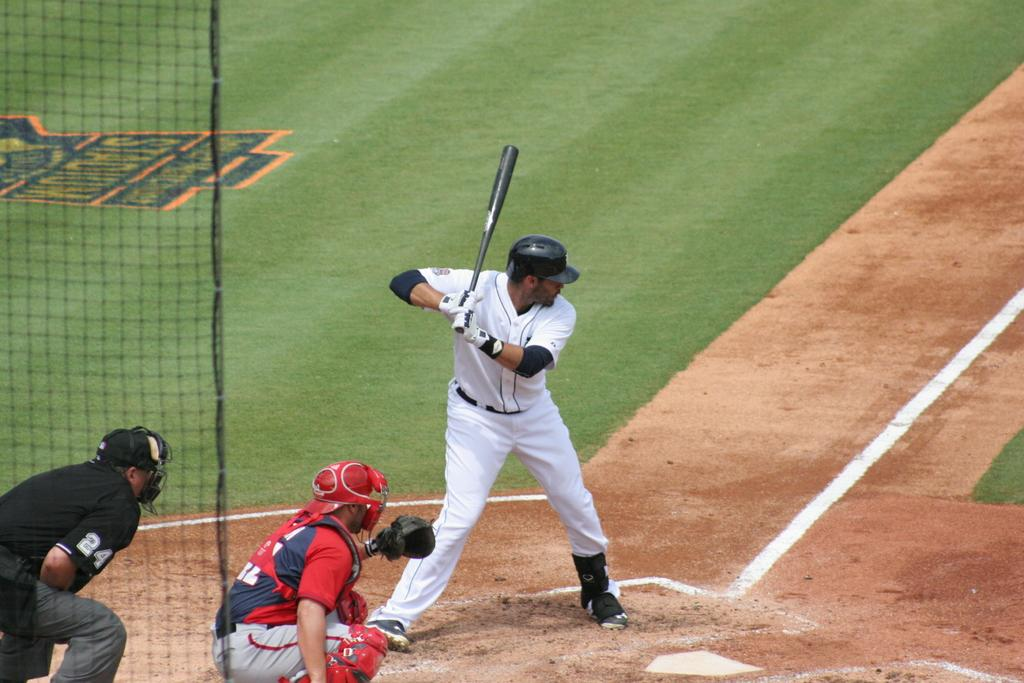<image>
Relay a brief, clear account of the picture shown. an umpire is behind the catcher and has 24 on his sleeve 